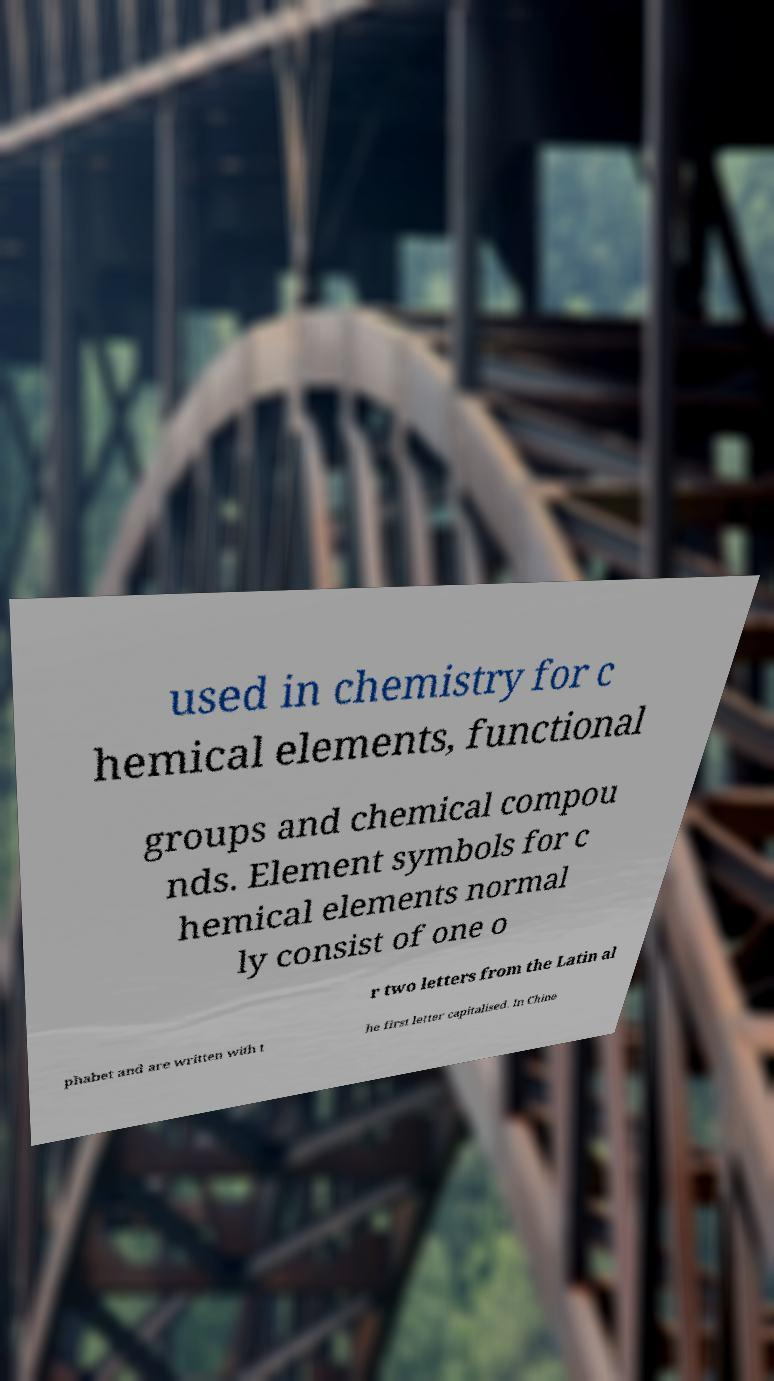I need the written content from this picture converted into text. Can you do that? used in chemistry for c hemical elements, functional groups and chemical compou nds. Element symbols for c hemical elements normal ly consist of one o r two letters from the Latin al phabet and are written with t he first letter capitalised. In Chine 